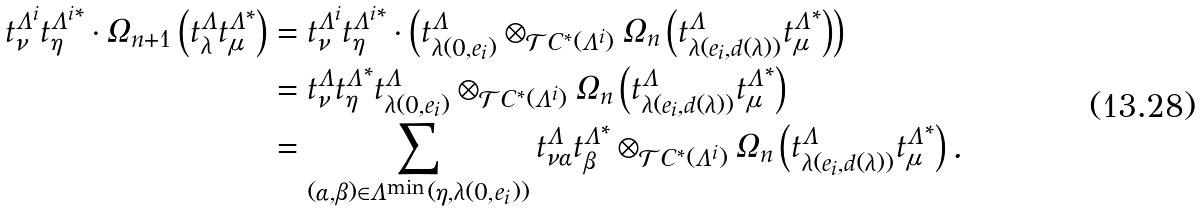<formula> <loc_0><loc_0><loc_500><loc_500>t _ { \nu } ^ { \Lambda ^ { i } } { t _ { \eta } ^ { \Lambda ^ { i } } } ^ { * } \cdot \Omega _ { n + 1 } \left ( t _ { \lambda } ^ { \Lambda } { t _ { \mu } ^ { \Lambda } } ^ { * } \right ) & = t _ { \nu } ^ { \Lambda ^ { i } } { t _ { \eta } ^ { \Lambda ^ { i } } } ^ { * } \cdot \left ( t _ { \lambda ( 0 , e _ { i } ) } ^ { \Lambda } \otimes _ { \mathcal { T } C ^ { * } ( \Lambda ^ { i } ) } \Omega _ { n } \left ( t _ { \lambda ( e _ { i } , d ( \lambda ) ) } ^ { \Lambda } { t _ { \mu } ^ { \Lambda } } ^ { * } \right ) \right ) \\ & = t _ { \nu } ^ { \Lambda } { t _ { \eta } ^ { \Lambda } } ^ { * } t _ { \lambda ( 0 , e _ { i } ) } ^ { \Lambda } \otimes _ { \mathcal { T } C ^ { * } ( \Lambda ^ { i } ) } \Omega _ { n } \left ( t _ { \lambda ( e _ { i } , d ( \lambda ) ) } ^ { \Lambda } { t _ { \mu } ^ { \Lambda } } ^ { * } \right ) \\ & = \sum _ { ( \alpha , \beta ) \in \Lambda ^ { \min } ( \eta , \lambda ( 0 , e _ { i } ) ) } t _ { \nu \alpha } ^ { \Lambda } { t _ { \beta } ^ { \Lambda } } ^ { * } \otimes _ { \mathcal { T } C ^ { * } ( \Lambda ^ { i } ) } \Omega _ { n } \left ( t _ { \lambda ( e _ { i } , d ( \lambda ) ) } ^ { \Lambda } { t _ { \mu } ^ { \Lambda } } ^ { * } \right ) .</formula> 